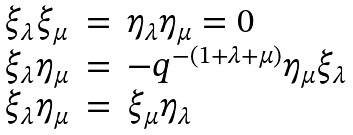Convert formula to latex. <formula><loc_0><loc_0><loc_500><loc_500>\begin{array} { l l l } \xi _ { \lambda } \xi _ { \mu } & = & \eta _ { \lambda } \eta _ { \mu } = 0 \\ \xi _ { \lambda } \eta _ { \mu } & = & - q ^ { - ( 1 + \lambda + \mu ) } \eta _ { \mu } \xi _ { \lambda } \\ \xi _ { \lambda } \eta _ { \mu } & = & \xi _ { \mu } \eta _ { \lambda } \end{array}</formula> 